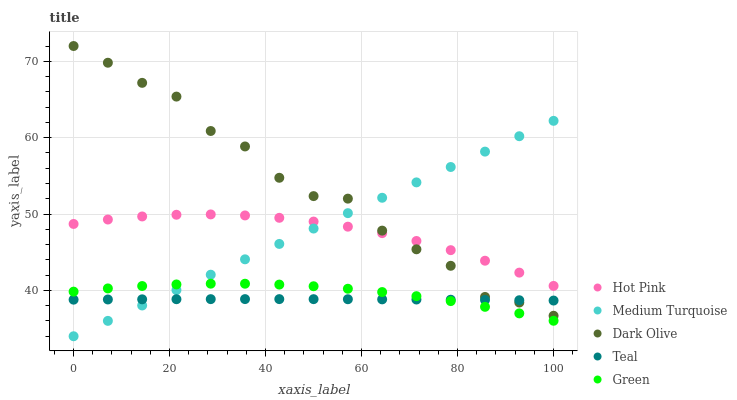Does Teal have the minimum area under the curve?
Answer yes or no. Yes. Does Dark Olive have the maximum area under the curve?
Answer yes or no. Yes. Does Hot Pink have the minimum area under the curve?
Answer yes or no. No. Does Hot Pink have the maximum area under the curve?
Answer yes or no. No. Is Medium Turquoise the smoothest?
Answer yes or no. Yes. Is Dark Olive the roughest?
Answer yes or no. Yes. Is Hot Pink the smoothest?
Answer yes or no. No. Is Hot Pink the roughest?
Answer yes or no. No. Does Medium Turquoise have the lowest value?
Answer yes or no. Yes. Does Green have the lowest value?
Answer yes or no. No. Does Dark Olive have the highest value?
Answer yes or no. Yes. Does Hot Pink have the highest value?
Answer yes or no. No. Is Teal less than Hot Pink?
Answer yes or no. Yes. Is Hot Pink greater than Teal?
Answer yes or no. Yes. Does Teal intersect Dark Olive?
Answer yes or no. Yes. Is Teal less than Dark Olive?
Answer yes or no. No. Is Teal greater than Dark Olive?
Answer yes or no. No. Does Teal intersect Hot Pink?
Answer yes or no. No. 